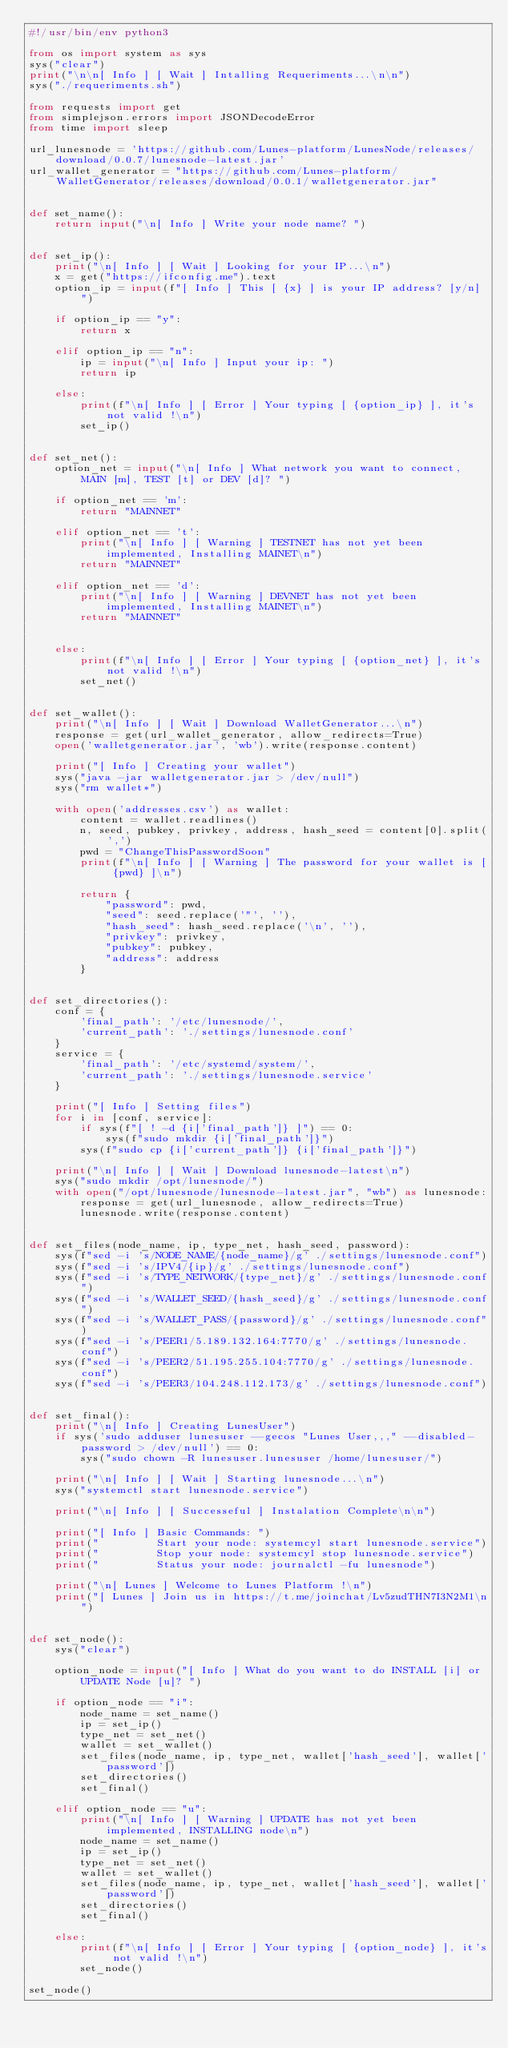<code> <loc_0><loc_0><loc_500><loc_500><_Python_>#!/usr/bin/env python3
    
from os import system as sys
sys("clear")    
print("\n\n[ Info ] [ Wait ] Intalling Requeriments...\n\n")
sys("./requeriments.sh")

from requests import get
from simplejson.errors import JSONDecodeError
from time import sleep

url_lunesnode = 'https://github.com/Lunes-platform/LunesNode/releases/download/0.0.7/lunesnode-latest.jar'
url_wallet_generator = "https://github.com/Lunes-platform/WalletGenerator/releases/download/0.0.1/walletgenerator.jar"


def set_name():
    return input("\n[ Info ] Write your node name? ")


def set_ip():
    print("\n[ Info ] [ Wait ] Looking for your IP...\n")
    x = get("https://ifconfig.me").text
    option_ip = input(f"[ Info ] This [ {x} ] is your IP address? [y/n] ")

    if option_ip == "y":
        return x

    elif option_ip == "n":
        ip = input("\n[ Info ] Input your ip: ")
        return ip

    else:
        print(f"\n[ Info ] [ Error ] Your typing [ {option_ip} ], it's not valid !\n")
        set_ip()


def set_net():
    option_net = input("\n[ Info ] What network you want to connect, MAIN [m], TEST [t] or DEV [d]? ")

    if option_net == 'm':
        return "MAINNET"

    elif option_net == 't':
        print("\n[ Info ] [ Warning ] TESTNET has not yet been implemented, Installing MAINET\n")
        return "MAINNET"

    elif option_net == 'd':
        print("\n[ Info ] [ Warning ] DEVNET has not yet been implemented, Installing MAINET\n")
        return "MAINNET"


    else:
        print(f"\n[ Info ] [ Error ] Your typing [ {option_net} ], it's not valid !\n")
        set_net()


def set_wallet():
    print("\n[ Info ] [ Wait ] Download WalletGenerator...\n")
    response = get(url_wallet_generator, allow_redirects=True)
    open('walletgenerator.jar', 'wb').write(response.content)

    print("[ Info ] Creating your wallet")
    sys("java -jar walletgenerator.jar > /dev/null")
    sys("rm wallet*")

    with open('addresses.csv') as wallet:
        content = wallet.readlines()
        n, seed, pubkey, privkey, address, hash_seed = content[0].split(',')
        pwd = "ChangeThisPasswordSoon"
        print(f"\n[ Info ] [ Warning ] The password for your wallet is [ {pwd} ]\n")

        return {
            "password": pwd,
            "seed": seed.replace('"', ''),
            "hash_seed": hash_seed.replace('\n', ''),
            "privkey": privkey,
            "pubkey": pubkey,
            "address": address
        }


def set_directories():
    conf = {
        'final_path': '/etc/lunesnode/',
        'current_path': './settings/lunesnode.conf'
    }
    service = {
        'final_path': '/etc/systemd/system/',
        'current_path': './settings/lunesnode.service'
    }

    print("[ Info ] Setting files")
    for i in [conf, service]:
        if sys(f"[ ! -d {i['final_path']} ]") == 0:
            sys(f"sudo mkdir {i['final_path']}")
        sys(f"sudo cp {i['current_path']} {i['final_path']}")

    print("\n[ Info ] [ Wait ] Download lunesnode-latest\n")
    sys("sudo mkdir /opt/lunesnode/")
    with open("/opt/lunesnode/lunesnode-latest.jar", "wb") as lunesnode:
        response = get(url_lunesnode, allow_redirects=True)
        lunesnode.write(response.content)


def set_files(node_name, ip, type_net, hash_seed, password):
    sys(f"sed -i 's/NODE_NAME/{node_name}/g' ./settings/lunesnode.conf")
    sys(f"sed -i 's/IPV4/{ip}/g' ./settings/lunesnode.conf")
    sys(f"sed -i 's/TYPE_NETWORK/{type_net}/g' ./settings/lunesnode.conf")
    sys(f"sed -i 's/WALLET_SEED/{hash_seed}/g' ./settings/lunesnode.conf")
    sys(f"sed -i 's/WALLET_PASS/{password}/g' ./settings/lunesnode.conf")
    sys(f"sed -i 's/PEER1/5.189.132.164:7770/g' ./settings/lunesnode.conf")
    sys(f"sed -i 's/PEER2/51.195.255.104:7770/g' ./settings/lunesnode.conf")
    sys(f"sed -i 's/PEER3/104.248.112.173/g' ./settings/lunesnode.conf")


def set_final():
    print("\n[ Info ] Creating LunesUser")
    if sys('sudo adduser lunesuser --gecos "Lunes User,,," --disabled-password > /dev/null') == 0:
        sys("sudo chown -R lunesuser.lunesuser /home/lunesuser/")

    print("\n[ Info ] [ Wait ] Starting lunesnode...\n")
    sys("systemctl start lunesnode.service")

    print("\n[ Info ] [ Successeful ] Instalation Complete\n\n")

    print("[ Info ] Basic Commands: ")
    print("         Start your node: systemcyl start lunesnode.service")
    print("         Stop your node: systemcyl stop lunesnode.service")
    print("         Status your node: journalctl -fu lunesnode")

    print("\n[ Lunes ] Welcome to Lunes Platform !\n")
    print("[ Lunes ] Join us in https://t.me/joinchat/Lv5zudTHN7I3N2M1\n")


def set_node():
    sys("clear")

    option_node = input("[ Info ] What do you want to do INSTALL [i] or UPDATE Node [u]? ")

    if option_node == "i":
        node_name = set_name()
        ip = set_ip()
        type_net = set_net()
        wallet = set_wallet()
        set_files(node_name, ip, type_net, wallet['hash_seed'], wallet['password'])
        set_directories()
        set_final()

    elif option_node == "u":
        print("\n[ Info ] [ Warning ] UPDATE has not yet been implemented, INSTALLING node\n")
        node_name = set_name()
        ip = set_ip()
        type_net = set_net()
        wallet = set_wallet()
        set_files(node_name, ip, type_net, wallet['hash_seed'], wallet['password'])
        set_directories()
        set_final()

    else:
        print(f"\n[ Info ] [ Error ] Your typing [ {option_node} ], it's not valid !\n")
        set_node()

set_node()
</code> 